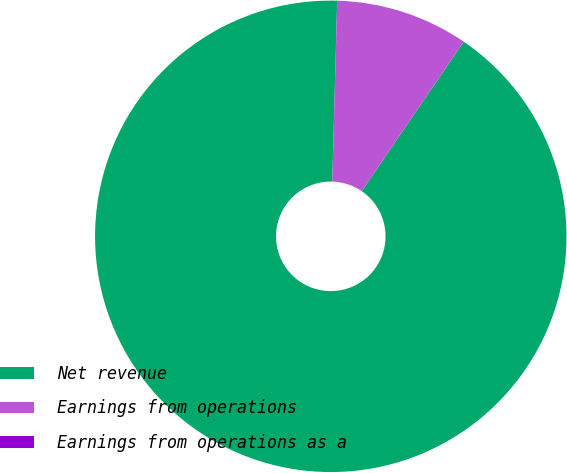<chart> <loc_0><loc_0><loc_500><loc_500><pie_chart><fcel>Net revenue<fcel>Earnings from operations<fcel>Earnings from operations as a<nl><fcel>90.9%<fcel>9.1%<fcel>0.01%<nl></chart> 